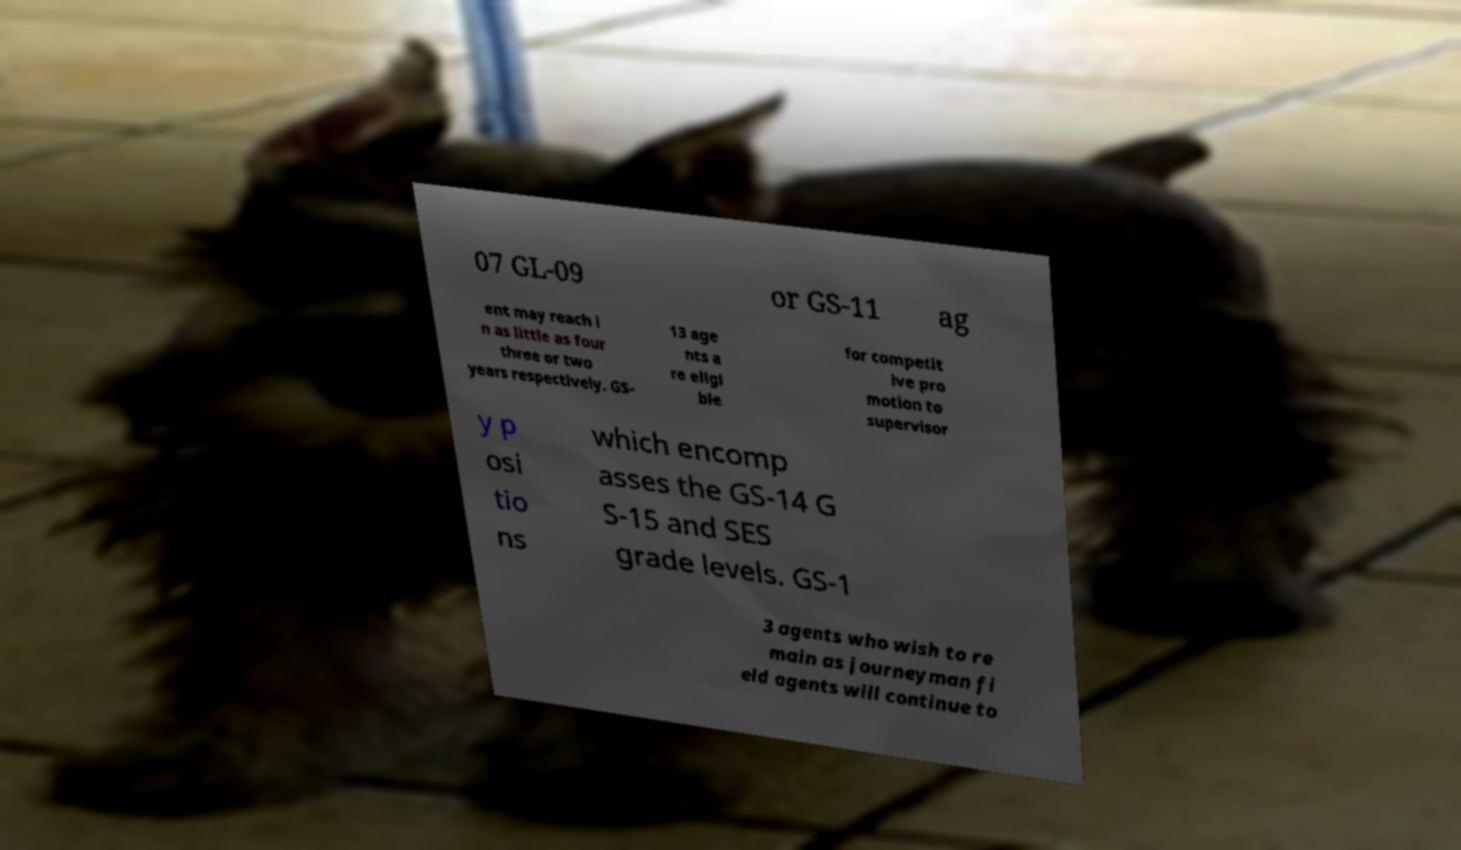I need the written content from this picture converted into text. Can you do that? 07 GL-09 or GS-11 ag ent may reach i n as little as four three or two years respectively. GS- 13 age nts a re eligi ble for competit ive pro motion to supervisor y p osi tio ns which encomp asses the GS-14 G S-15 and SES grade levels. GS-1 3 agents who wish to re main as journeyman fi eld agents will continue to 